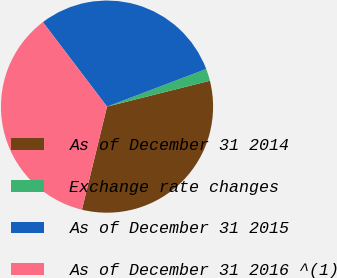<chart> <loc_0><loc_0><loc_500><loc_500><pie_chart><fcel>As of December 31 2014<fcel>Exchange rate changes<fcel>As of December 31 2015<fcel>As of December 31 2016 ^(1)<nl><fcel>32.72%<fcel>1.85%<fcel>29.56%<fcel>35.87%<nl></chart> 